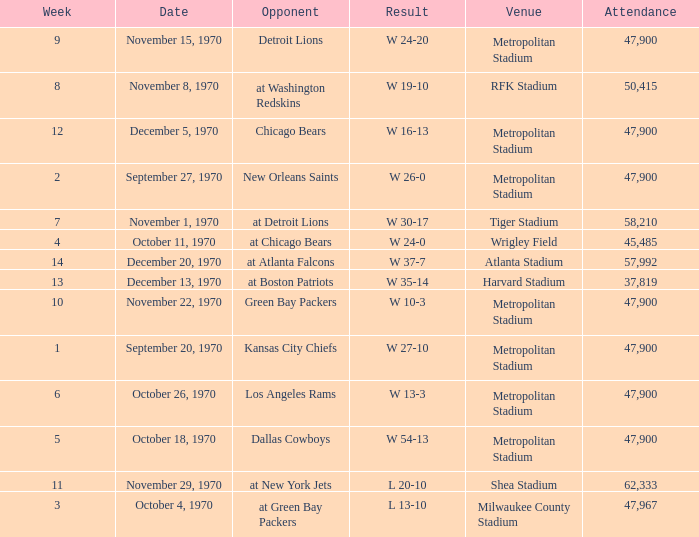How many people attended the game with a result of w 16-13 and a week earlier than 12? None. 